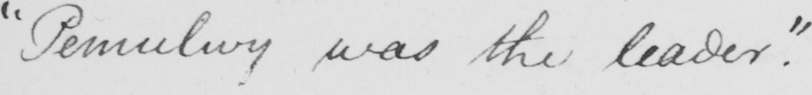What text is written in this handwritten line? " Pemulwy was the leader . " 